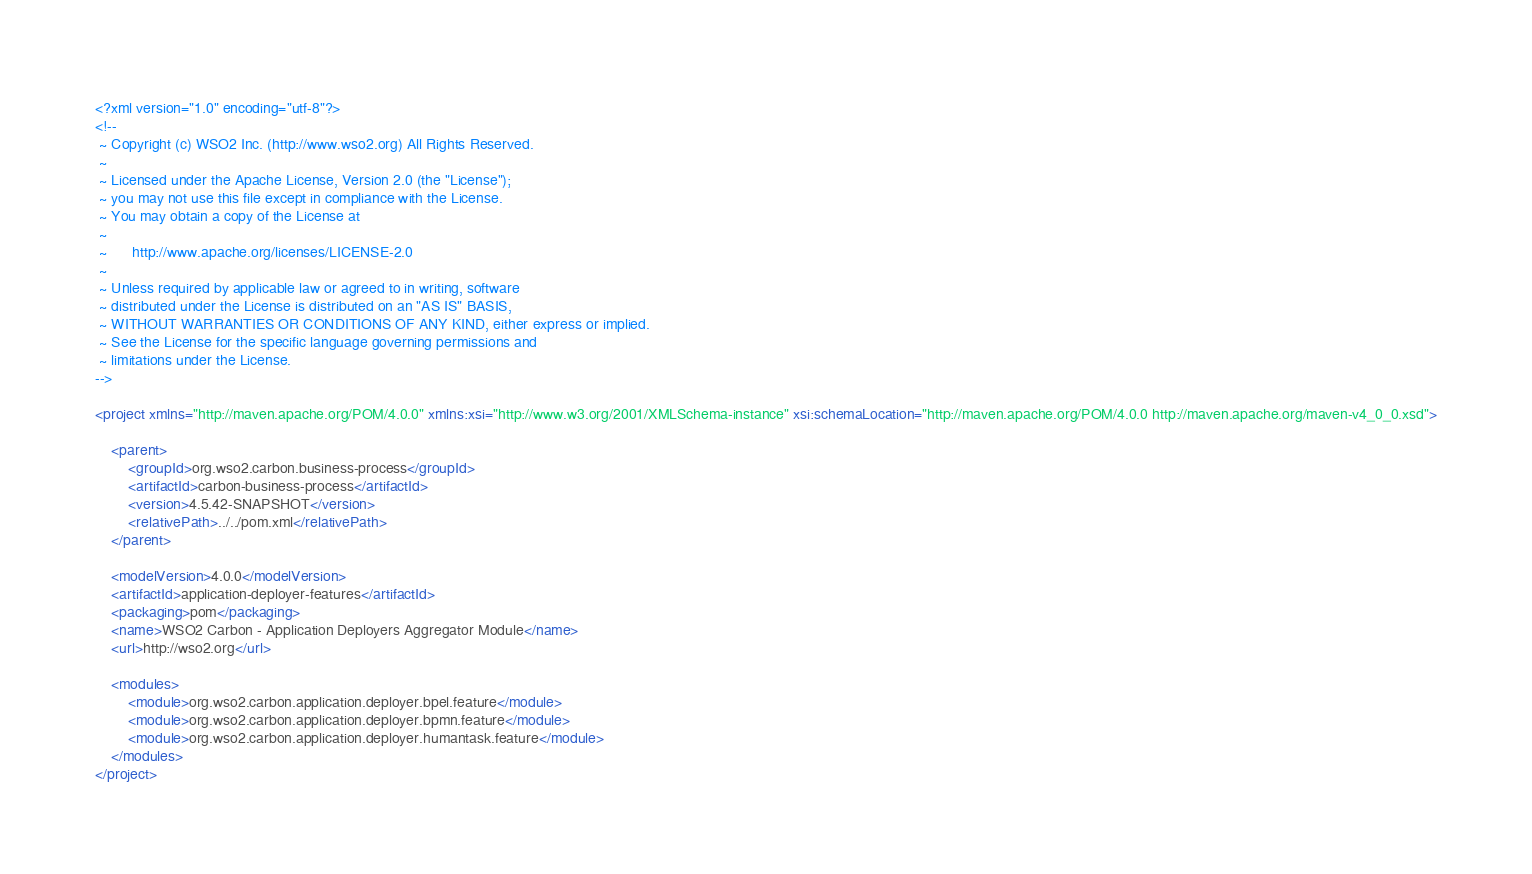<code> <loc_0><loc_0><loc_500><loc_500><_XML_><?xml version="1.0" encoding="utf-8"?>
<!--
 ~ Copyright (c) WSO2 Inc. (http://www.wso2.org) All Rights Reserved.
 ~
 ~ Licensed under the Apache License, Version 2.0 (the "License");
 ~ you may not use this file except in compliance with the License.
 ~ You may obtain a copy of the License at
 ~
 ~      http://www.apache.org/licenses/LICENSE-2.0
 ~
 ~ Unless required by applicable law or agreed to in writing, software
 ~ distributed under the License is distributed on an "AS IS" BASIS,
 ~ WITHOUT WARRANTIES OR CONDITIONS OF ANY KIND, either express or implied.
 ~ See the License for the specific language governing permissions and
 ~ limitations under the License.
-->

<project xmlns="http://maven.apache.org/POM/4.0.0" xmlns:xsi="http://www.w3.org/2001/XMLSchema-instance" xsi:schemaLocation="http://maven.apache.org/POM/4.0.0 http://maven.apache.org/maven-v4_0_0.xsd">

    <parent>
        <groupId>org.wso2.carbon.business-process</groupId>
        <artifactId>carbon-business-process</artifactId>
        <version>4.5.42-SNAPSHOT</version>
        <relativePath>../../pom.xml</relativePath>
    </parent>

    <modelVersion>4.0.0</modelVersion>
    <artifactId>application-deployer-features</artifactId>
    <packaging>pom</packaging>
    <name>WSO2 Carbon - Application Deployers Aggregator Module</name>
    <url>http://wso2.org</url>

    <modules>
        <module>org.wso2.carbon.application.deployer.bpel.feature</module>
        <module>org.wso2.carbon.application.deployer.bpmn.feature</module>
        <module>org.wso2.carbon.application.deployer.humantask.feature</module>
    </modules>
</project>

</code> 